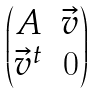<formula> <loc_0><loc_0><loc_500><loc_500>\begin{pmatrix} A & \vec { v } \\ \vec { v } ^ { t } & 0 \\ \end{pmatrix}</formula> 